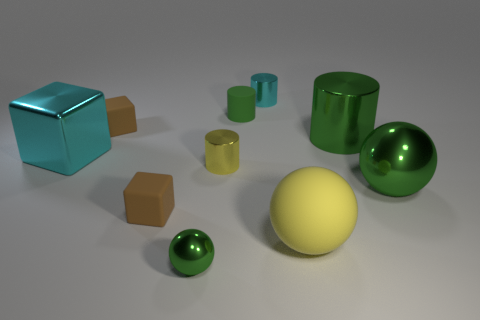What color is the big thing that is the same shape as the small green matte thing?
Your answer should be very brief. Green. Is there any other thing that has the same shape as the small green matte thing?
Ensure brevity in your answer.  Yes. The big object that is made of the same material as the small green cylinder is what color?
Make the answer very short. Yellow. Are there any green shiny spheres that are in front of the big metallic object to the left of the small cyan metal thing that is left of the big green shiny cylinder?
Offer a terse response. Yes. Is the number of brown matte cubes in front of the big cube less than the number of objects that are behind the yellow metal thing?
Your response must be concise. Yes. What number of brown things have the same material as the cyan cylinder?
Keep it short and to the point. 0. There is a yellow matte object; is its size the same as the green shiny thing behind the big cyan shiny thing?
Ensure brevity in your answer.  Yes. There is a tiny cylinder that is the same color as the large cylinder; what is its material?
Your answer should be compact. Rubber. There is a cube right of the brown rubber cube behind the cylinder that is on the right side of the yellow rubber ball; what is its size?
Your answer should be compact. Small. Are there more small cylinders that are in front of the large metal cylinder than large blocks that are in front of the large yellow matte sphere?
Your answer should be very brief. Yes. 